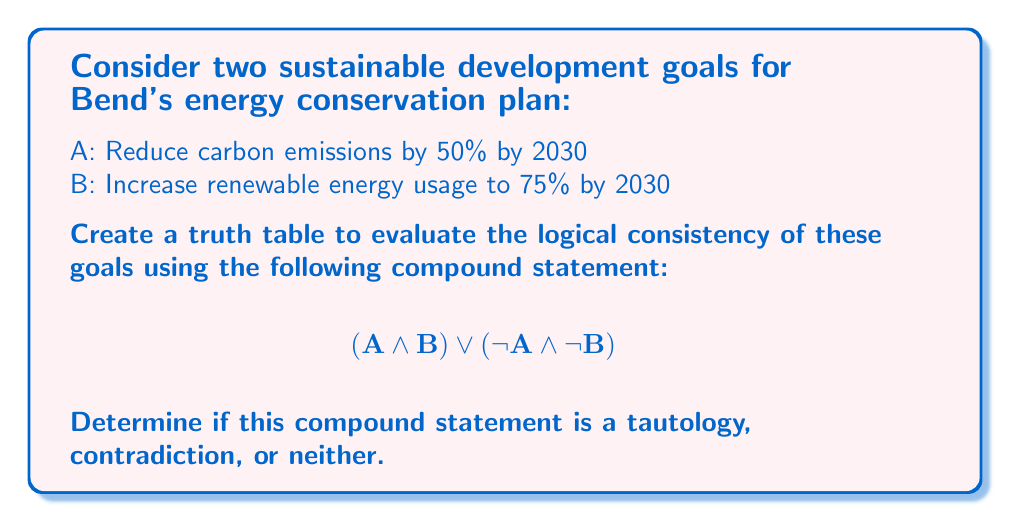Give your solution to this math problem. To evaluate the logical consistency of these sustainable development goals, we need to construct a truth table for the given compound statement:

$$(A \land B) \lor (\neg A \land \neg B)$$

Let's break this down step-by-step:

1. First, we'll create a truth table with columns for A, B, and intermediate steps:

   | A | B | $A \land B$ | $\neg A$ | $\neg B$ | $\neg A \land \neg B$ | $(A \land B) \lor (\neg A \land \neg B)$ |
   |---|---|-------------|----------|----------|----------------------|------------------------------------------|
   | T | T |             |          |          |                      |                                          |
   | T | F |             |          |          |                      |                                          |
   | F | T |             |          |          |                      |                                          |
   | F | F |             |          |          |                      |                                          |

2. Now, let's fill in the intermediate columns:

   | A | B | $A \land B$ | $\neg A$ | $\neg B$ | $\neg A \land \neg B$ | $(A \land B) \lor (\neg A \land \neg B)$ |
   |---|---|-------------|----------|----------|----------------------|------------------------------------------|
   | T | T | T           | F        | F        | F                    | T                                        |
   | T | F | F           | F        | T        | F                    | F                                        |
   | F | T | F           | T        | F        | F                    | F                                        |
   | F | F | F           | T        | T        | T                    | T                                        |

3. Analyzing the results:
   - The compound statement is true when both A and B are true (both goals are achieved) or when both A and B are false (neither goal is achieved).
   - The compound statement is false when only one of the goals is achieved.

4. To determine if this is a tautology, contradiction, or neither:
   - A tautology is always true (all T in the final column)
   - A contradiction is always false (all F in the final column)
   - Neither a tautology nor a contradiction has both T and F in the final column

In this case, we see both T and F in the final column, so it is neither a tautology nor a contradiction.
Answer: The compound statement $$(A \land B) \lor (\neg A \land \neg B)$$ is neither a tautology nor a contradiction. It represents a logically consistent scenario where either both sustainable development goals are achieved or neither is achieved, but not a situation where only one goal is met. 